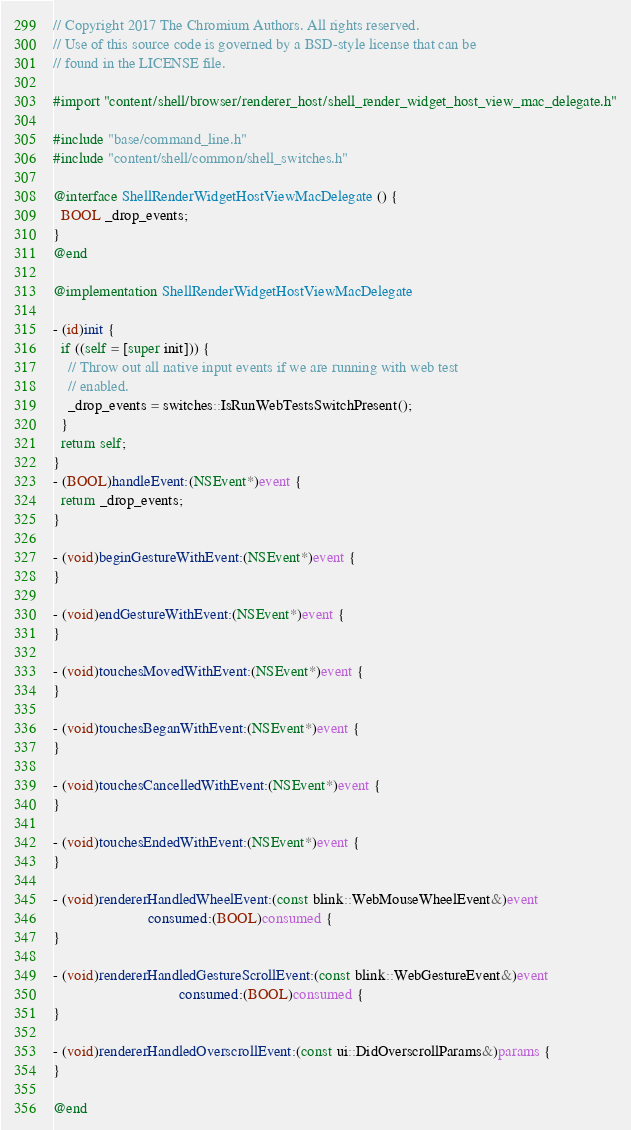Convert code to text. <code><loc_0><loc_0><loc_500><loc_500><_ObjectiveC_>// Copyright 2017 The Chromium Authors. All rights reserved.
// Use of this source code is governed by a BSD-style license that can be
// found in the LICENSE file.

#import "content/shell/browser/renderer_host/shell_render_widget_host_view_mac_delegate.h"

#include "base/command_line.h"
#include "content/shell/common/shell_switches.h"

@interface ShellRenderWidgetHostViewMacDelegate () {
  BOOL _drop_events;
}
@end

@implementation ShellRenderWidgetHostViewMacDelegate

- (id)init {
  if ((self = [super init])) {
    // Throw out all native input events if we are running with web test
    // enabled.
    _drop_events = switches::IsRunWebTestsSwitchPresent();
  }
  return self;
}
- (BOOL)handleEvent:(NSEvent*)event {
  return _drop_events;
}

- (void)beginGestureWithEvent:(NSEvent*)event {
}

- (void)endGestureWithEvent:(NSEvent*)event {
}

- (void)touchesMovedWithEvent:(NSEvent*)event {
}

- (void)touchesBeganWithEvent:(NSEvent*)event {
}

- (void)touchesCancelledWithEvent:(NSEvent*)event {
}

- (void)touchesEndedWithEvent:(NSEvent*)event {
}

- (void)rendererHandledWheelEvent:(const blink::WebMouseWheelEvent&)event
                         consumed:(BOOL)consumed {
}

- (void)rendererHandledGestureScrollEvent:(const blink::WebGestureEvent&)event
                                 consumed:(BOOL)consumed {
}

- (void)rendererHandledOverscrollEvent:(const ui::DidOverscrollParams&)params {
}

@end
</code> 